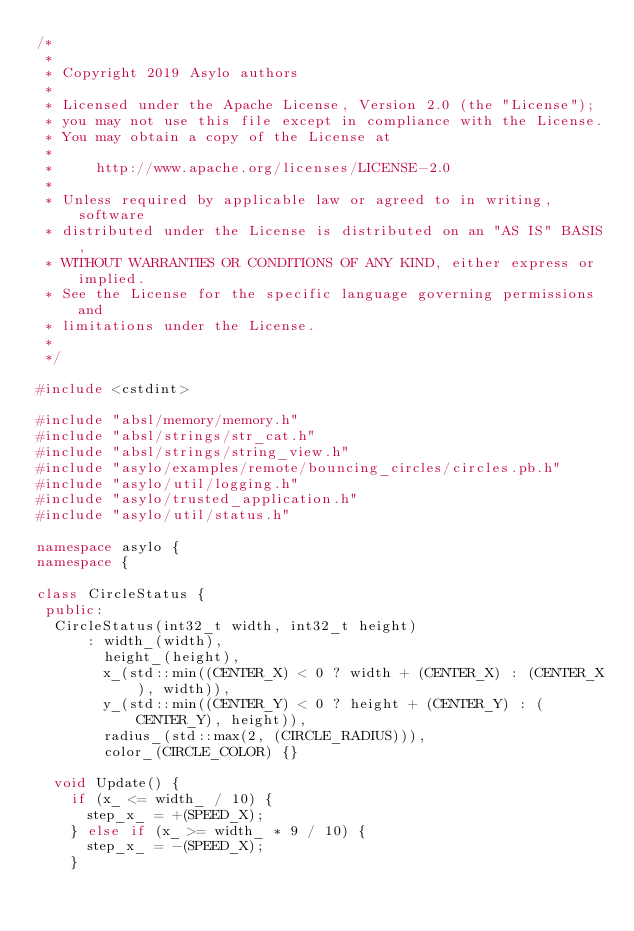<code> <loc_0><loc_0><loc_500><loc_500><_C++_>/*
 *
 * Copyright 2019 Asylo authors
 *
 * Licensed under the Apache License, Version 2.0 (the "License");
 * you may not use this file except in compliance with the License.
 * You may obtain a copy of the License at
 *
 *     http://www.apache.org/licenses/LICENSE-2.0
 *
 * Unless required by applicable law or agreed to in writing, software
 * distributed under the License is distributed on an "AS IS" BASIS,
 * WITHOUT WARRANTIES OR CONDITIONS OF ANY KIND, either express or implied.
 * See the License for the specific language governing permissions and
 * limitations under the License.
 *
 */

#include <cstdint>

#include "absl/memory/memory.h"
#include "absl/strings/str_cat.h"
#include "absl/strings/string_view.h"
#include "asylo/examples/remote/bouncing_circles/circles.pb.h"
#include "asylo/util/logging.h"
#include "asylo/trusted_application.h"
#include "asylo/util/status.h"

namespace asylo {
namespace {

class CircleStatus {
 public:
  CircleStatus(int32_t width, int32_t height)
      : width_(width),
        height_(height),
        x_(std::min((CENTER_X) < 0 ? width + (CENTER_X) : (CENTER_X), width)),
        y_(std::min((CENTER_Y) < 0 ? height + (CENTER_Y) : (CENTER_Y), height)),
        radius_(std::max(2, (CIRCLE_RADIUS))),
        color_(CIRCLE_COLOR) {}

  void Update() {
    if (x_ <= width_ / 10) {
      step_x_ = +(SPEED_X);
    } else if (x_ >= width_ * 9 / 10) {
      step_x_ = -(SPEED_X);
    }</code> 